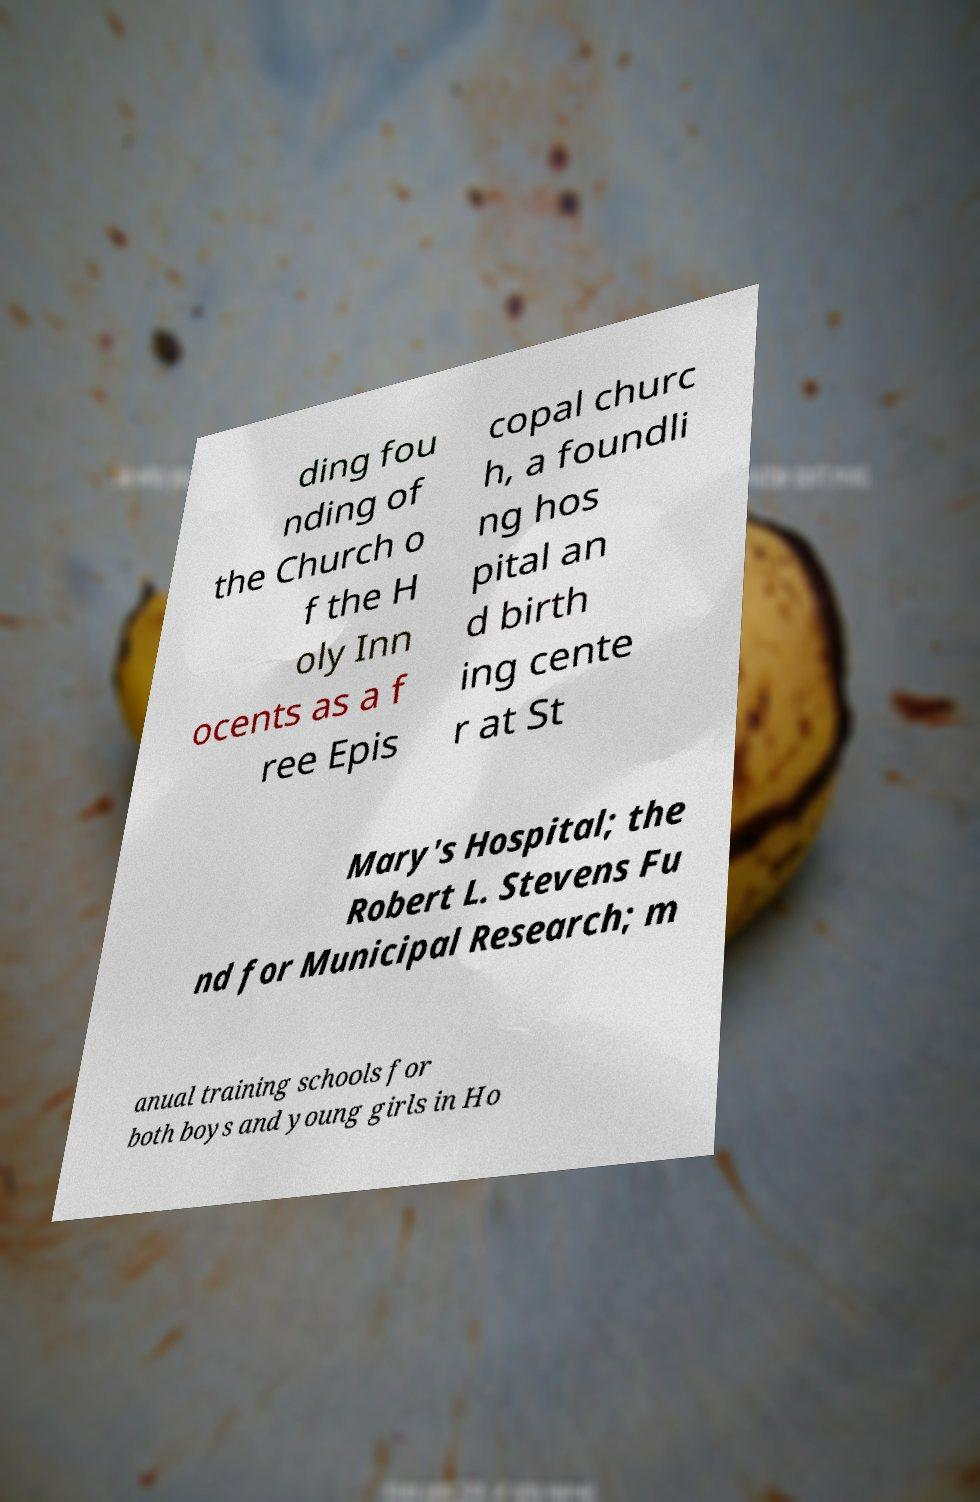Please read and relay the text visible in this image. What does it say? ding fou nding of the Church o f the H oly Inn ocents as a f ree Epis copal churc h, a foundli ng hos pital an d birth ing cente r at St Mary's Hospital; the Robert L. Stevens Fu nd for Municipal Research; m anual training schools for both boys and young girls in Ho 